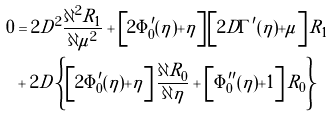<formula> <loc_0><loc_0><loc_500><loc_500>0 & = 2 D ^ { 2 } \frac { \partial ^ { 2 } R _ { 1 } } { \partial \mu ^ { 2 } } + \left [ 2 \Phi _ { 0 } ^ { \prime } ( \eta ) + \eta \right ] \left [ 2 D \Gamma ^ { \prime } ( \eta ) + \mu \right ] R _ { 1 } \\ & + 2 D \left \{ \left [ 2 \Phi _ { 0 } ^ { \prime } ( \eta ) + \eta \right ] \frac { \partial R _ { 0 } } { \partial \eta } + \left [ \Phi _ { 0 } ^ { \prime \prime } ( \eta ) + 1 \right ] R _ { 0 } \right \}</formula> 